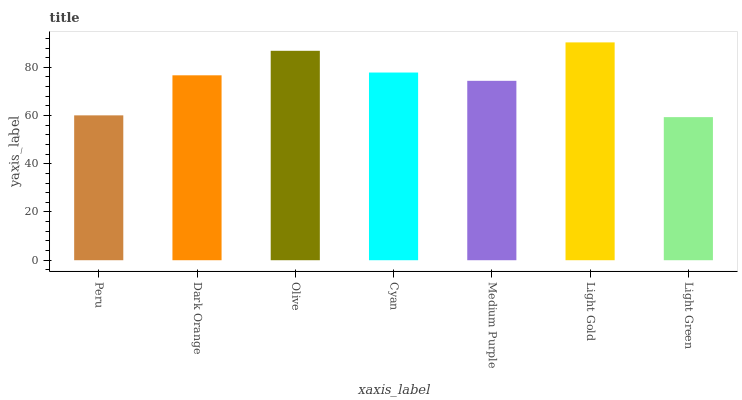Is Light Green the minimum?
Answer yes or no. Yes. Is Light Gold the maximum?
Answer yes or no. Yes. Is Dark Orange the minimum?
Answer yes or no. No. Is Dark Orange the maximum?
Answer yes or no. No. Is Dark Orange greater than Peru?
Answer yes or no. Yes. Is Peru less than Dark Orange?
Answer yes or no. Yes. Is Peru greater than Dark Orange?
Answer yes or no. No. Is Dark Orange less than Peru?
Answer yes or no. No. Is Dark Orange the high median?
Answer yes or no. Yes. Is Dark Orange the low median?
Answer yes or no. Yes. Is Light Green the high median?
Answer yes or no. No. Is Olive the low median?
Answer yes or no. No. 